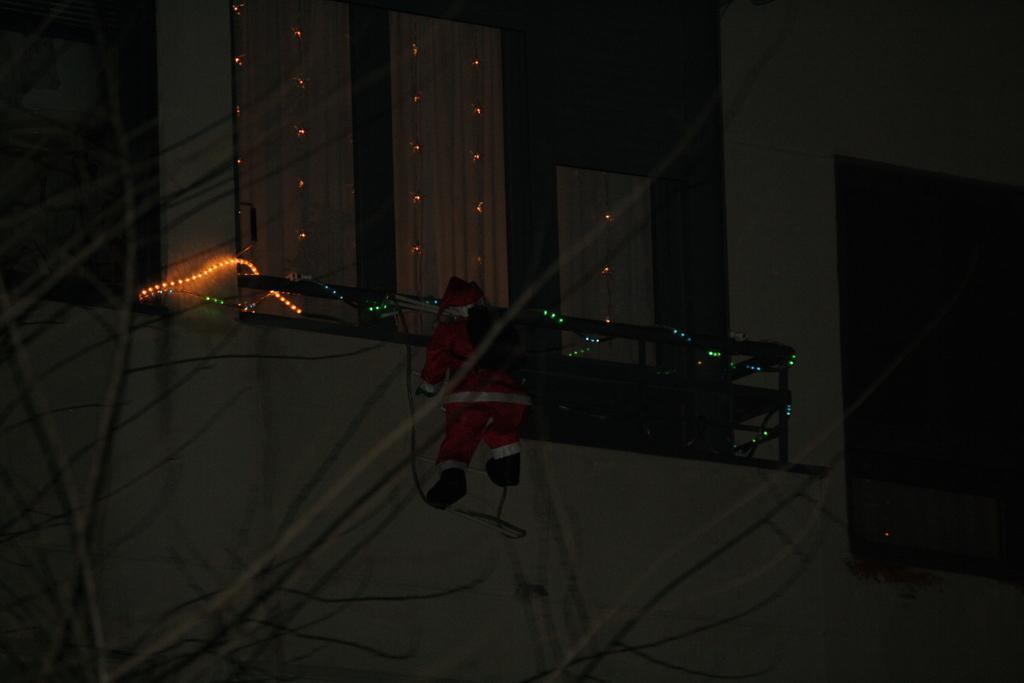In one or two sentences, can you explain what this image depicts? The picture is taken outside a building. In the foreground there are stems of a tree. In the center of the picture there are lights, windows and wall of a building. In the center of the picture there is Santa Claus hanging in the corridor. 